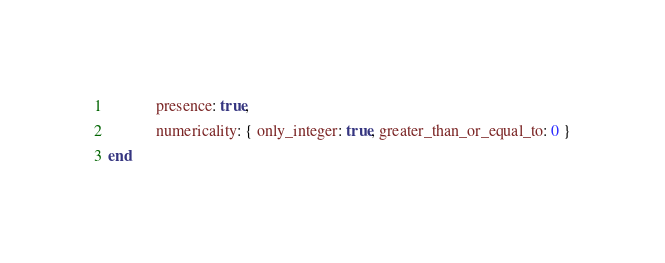<code> <loc_0><loc_0><loc_500><loc_500><_Ruby_>            presence: true,
            numericality: { only_integer: true, greater_than_or_equal_to: 0 }
end
</code> 